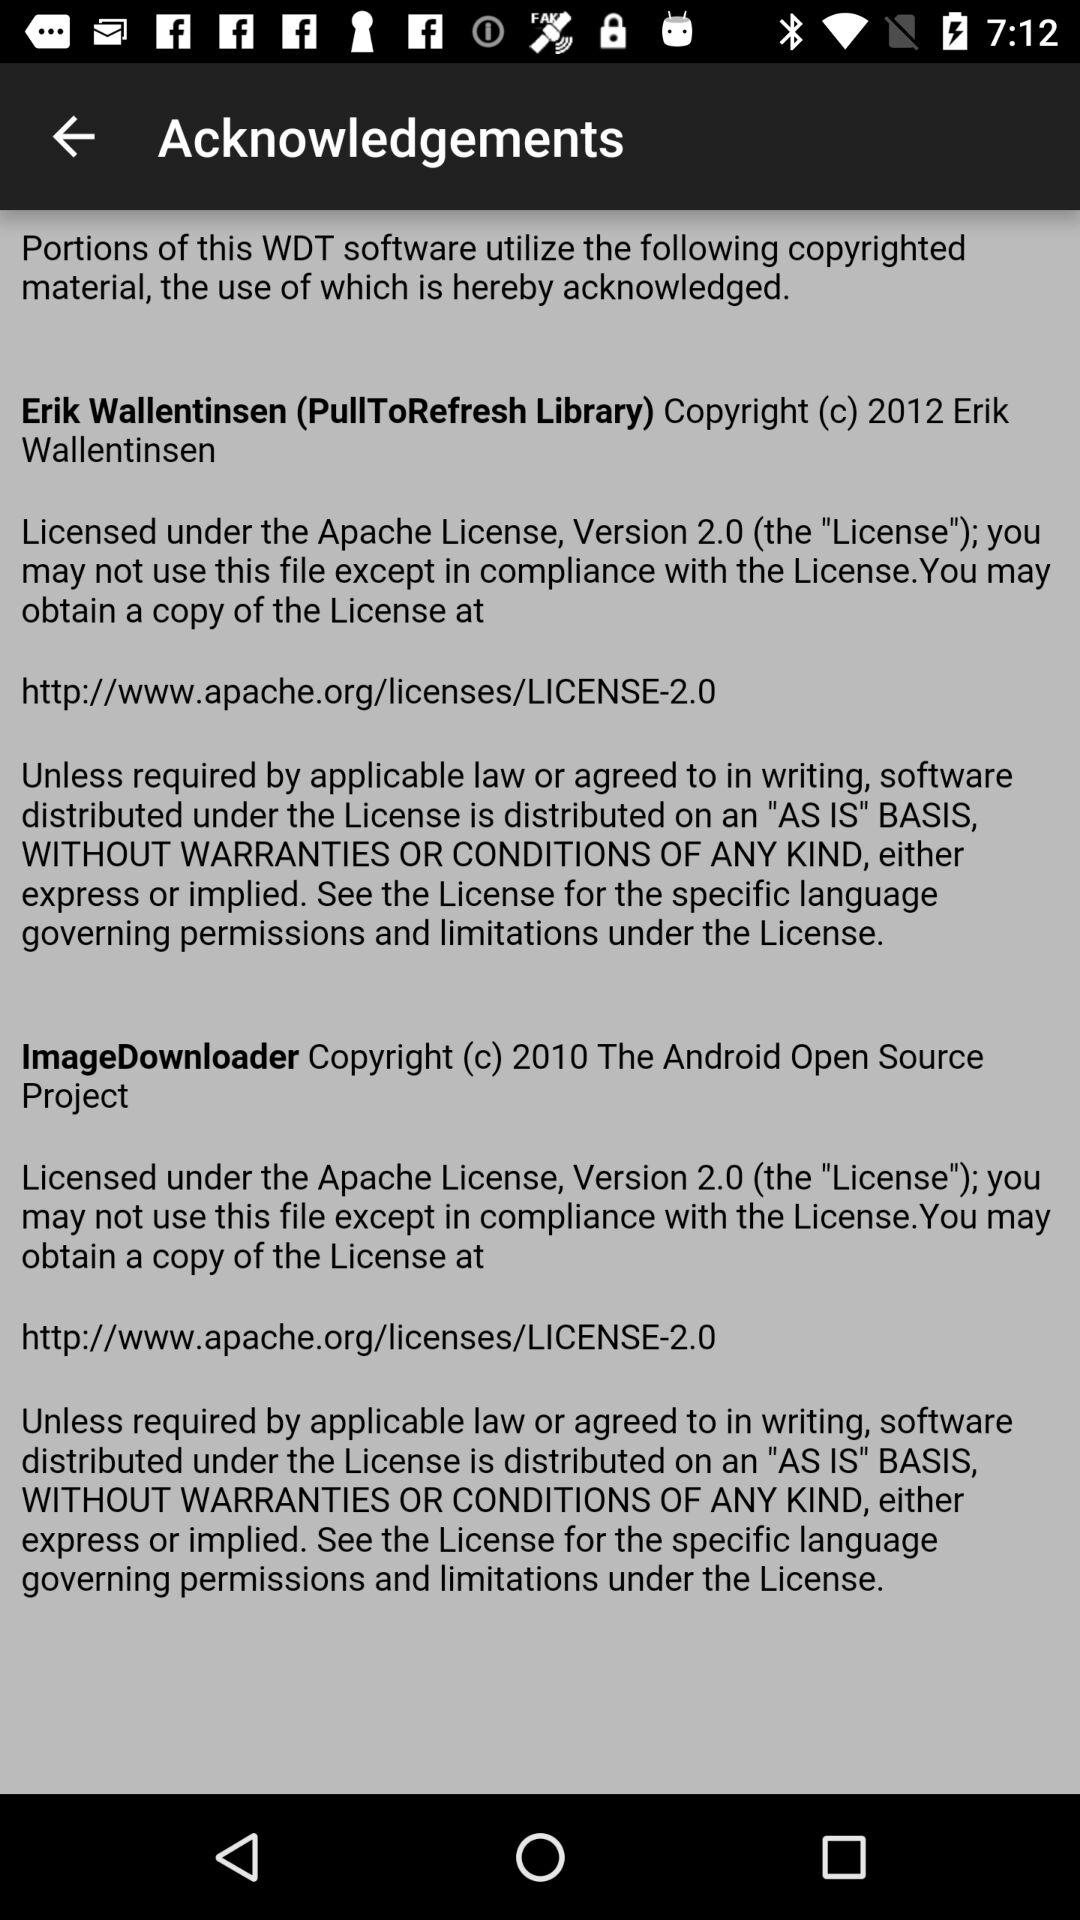What is the year of copyright of "Erik Wallentinsen"? The copyrght year is 2012. 